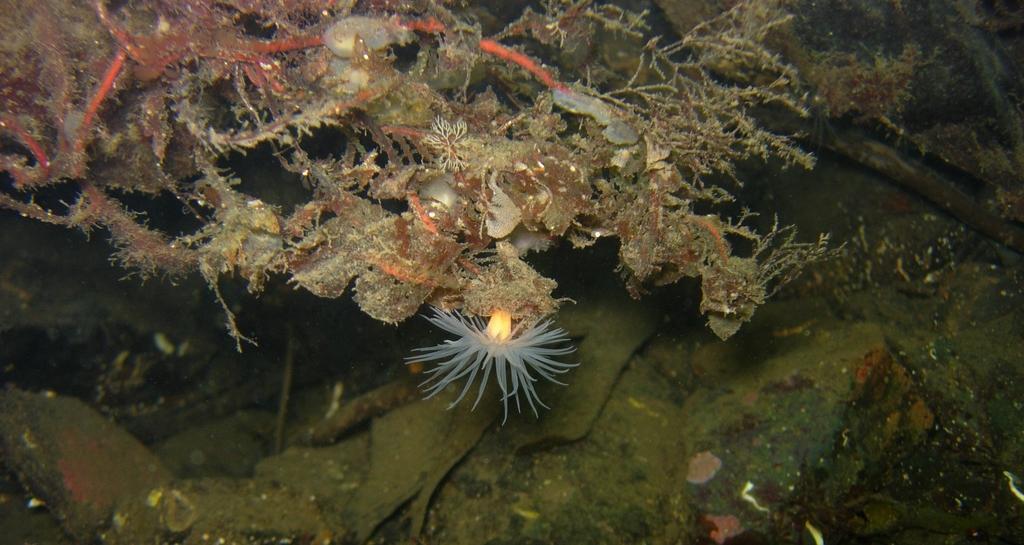How would you summarize this image in a sentence or two? In this image I can see the under water picture in which I can see few aquatic plants which are green, orange, cream and yellow in color and few other objects. 